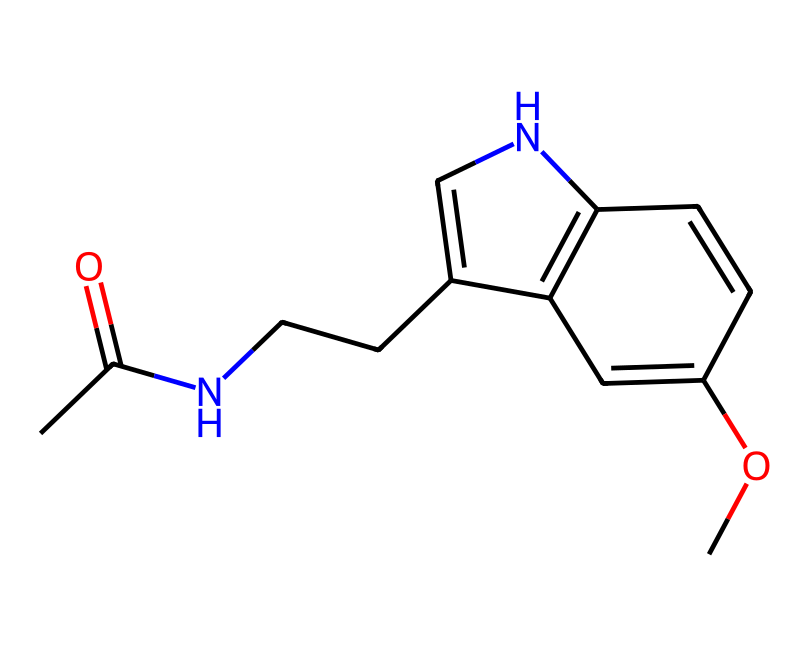What is the molecular formula of melatonin? To determine the molecular formula, we need to count the different types of atoms present in the structure shown. The SMILES representation indicates the presence of carbon (C), hydrogen (H), nitrogen (N), and oxygen (O) atoms. By analyzing the SMILES, we can summarize that the molecule has 13 carbon atoms, 16 hydrogen atoms, 2 nitrogen atoms, and 1 oxygen atom. So, the molecular formula is C13H16N2O.
Answer: C13H16N2O How many rings are in the structure of melatonin? By examining the chemical structure, we can identify the presence of a bicyclic structure. A ring is formed by atoms connected in a closed loop, and in the specified chemical, there are two such rings present.
Answer: 2 What type of functional group is primarily present in melatonin? The primary functional group in melatonin can be identified by looking for specific atom arrangements. The structure contains an acetamide group, which consists of a carbonyl (C=O) connected to a nitrogen atom (N), indicating the presence of an amide functional group.
Answer: amide How many hydrogen bond donors can melatonin exhibit? To determine the potential hydrogen bond donors, we look for the presence of nitrogen and oxygen atoms in the structure that can participate in hydrogen bonding. The molecule has one nitrogen atom that can donate a hydrogen bond, while the acetamide functional group can also donate through its carbonyl oxygen. Therefore, melatonin can act as a donor with these functional groups.
Answer: 2 Is melatonin a naturally occurring hormone? Referring to biological knowledge, melatonin is known as a naturally occurring hormone produced by the pineal gland in the brain, regulating sleep-wake cycles. This supports its classification as a hormone.
Answer: yes What role does melatonin play in the human body? Melatonin is primarily involved in the regulation of sleep. It helps to signal the body when it is time to sleep based on light exposure, thus playing a crucial role in the circadian rhythm.
Answer: sleep regulation 